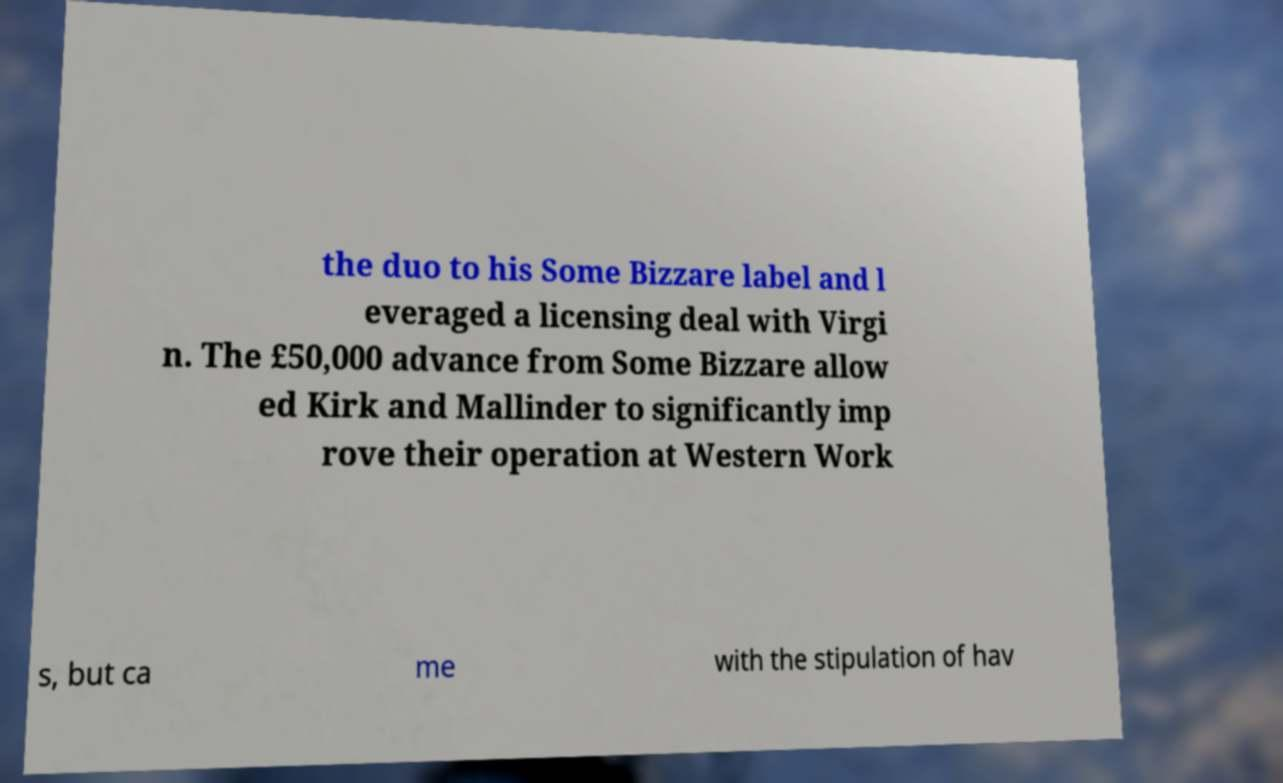Could you assist in decoding the text presented in this image and type it out clearly? the duo to his Some Bizzare label and l everaged a licensing deal with Virgi n. The £50,000 advance from Some Bizzare allow ed Kirk and Mallinder to significantly imp rove their operation at Western Work s, but ca me with the stipulation of hav 